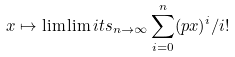Convert formula to latex. <formula><loc_0><loc_0><loc_500><loc_500>x \mapsto \lim \lim i t s _ { n \to \infty } \sum _ { i = 0 } ^ { n } ( p x ) ^ { i } / i !</formula> 